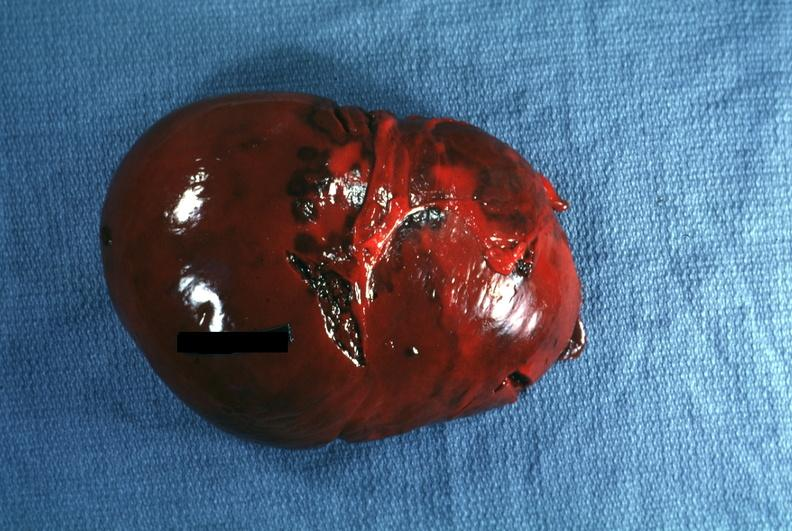s myomas seen seen?
Answer the question using a single word or phrase. No 